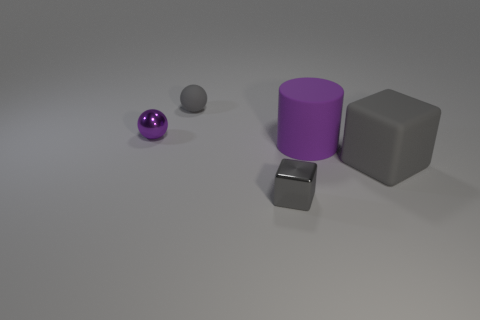What number of other things are made of the same material as the big purple object?
Provide a short and direct response. 2. What is the small cube made of?
Your answer should be very brief. Metal. What number of tiny objects are shiny cubes or purple shiny balls?
Keep it short and to the point. 2. There is a tiny cube; what number of tiny shiny balls are to the right of it?
Offer a terse response. 0. Are there any cubes that have the same color as the tiny matte thing?
Offer a very short reply. Yes. What shape is the object that is the same size as the matte cylinder?
Give a very brief answer. Cube. How many green things are small shiny things or matte cylinders?
Your answer should be compact. 0. What number of gray objects have the same size as the matte cylinder?
Keep it short and to the point. 1. There is a tiny matte thing that is the same color as the metal block; what is its shape?
Your answer should be very brief. Sphere. What number of things are small purple metal blocks or blocks that are to the right of the small metallic cube?
Provide a short and direct response. 1. 